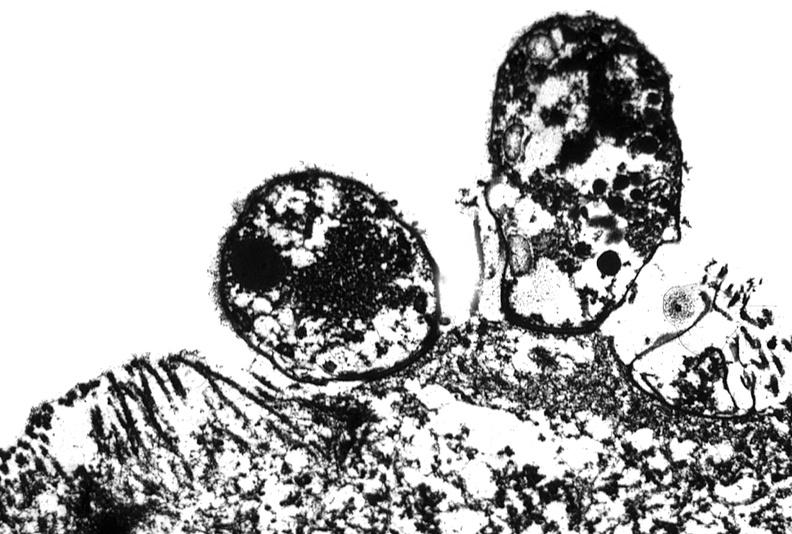where is this electron microscopy figure taken?
Answer the question using a single word or phrase. Gastrointestinal system 